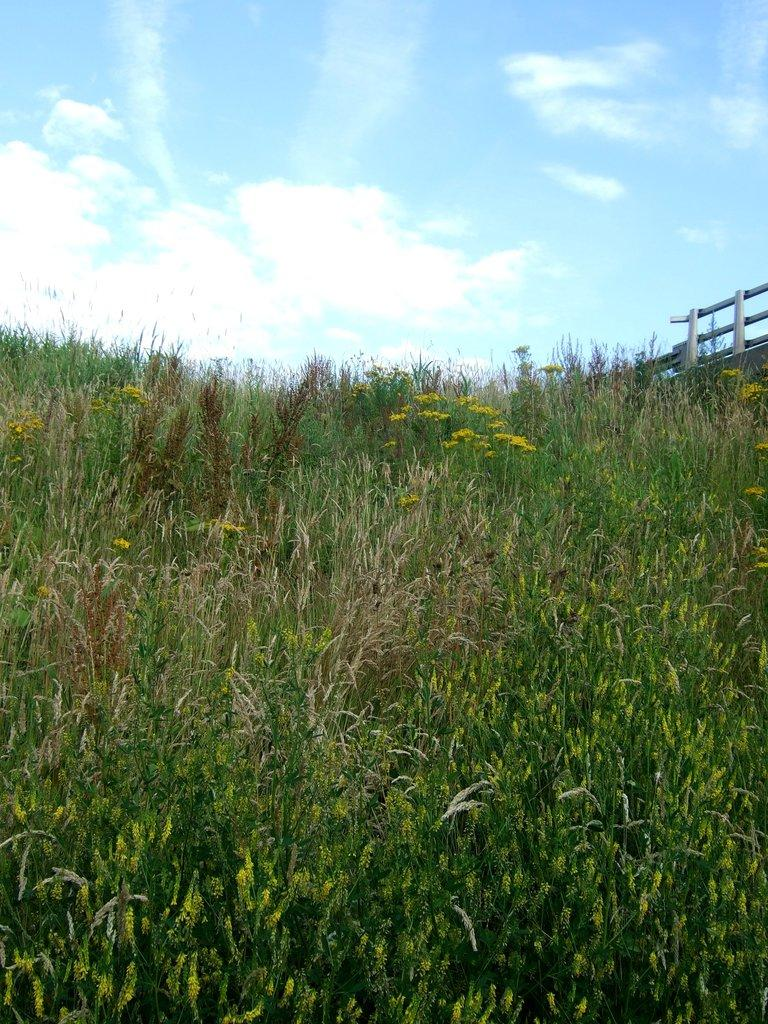What type of living organisms can be seen in the image? Plants can be seen in the image. What colors are present on the plants in the image? The plants have green, brown, and yellow colors. What can be seen in the background of the image? There is a railing and the sky visible in the background of the image. Can you tell me how many quarters are visible on the plants in the image? There are no quarters present on the plants in the image; they are plants, not coins. Is there an airplane flying in the sky in the image? There is no airplane visible in the sky in the image; only the sky and the railing can be seen in the background. 